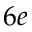<formula> <loc_0><loc_0><loc_500><loc_500>6 e</formula> 